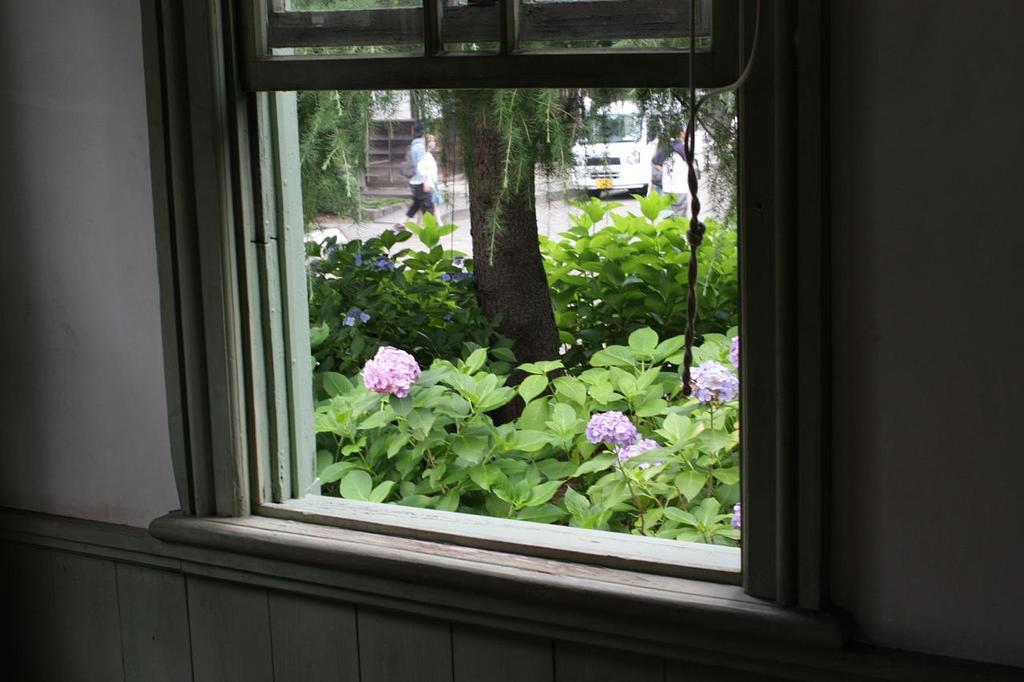Please provide a concise description of this image. We can see wall and window,through this window we can see plants,flowers,trees,people and vehicle. 